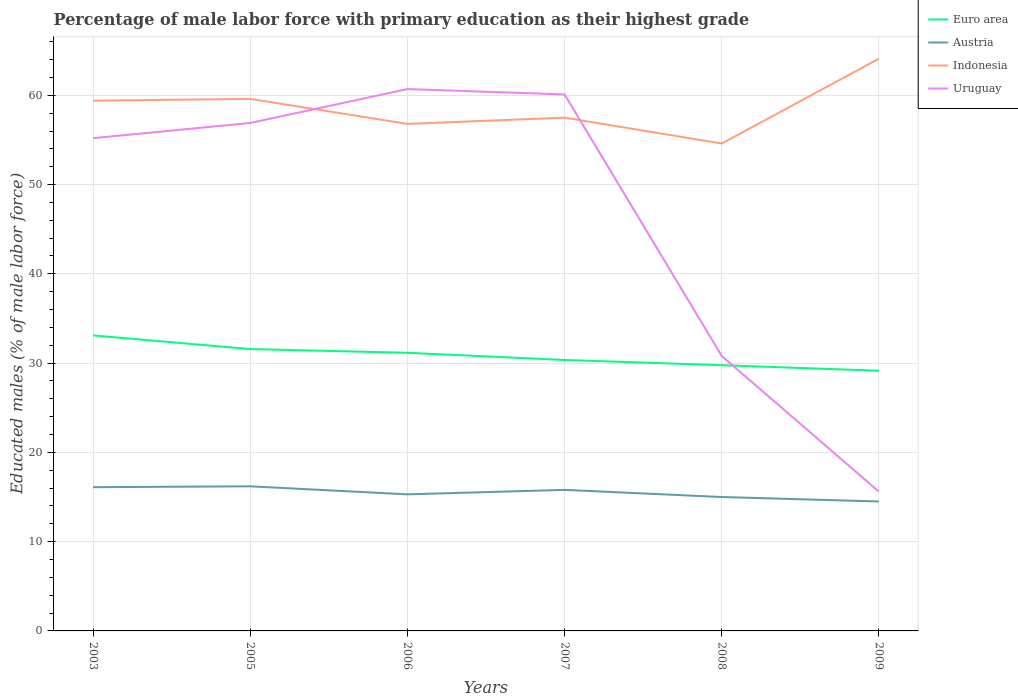Across all years, what is the maximum percentage of male labor force with primary education in Indonesia?
Offer a very short reply. 54.6. What is the total percentage of male labor force with primary education in Euro area in the graph?
Provide a succinct answer. 1.95. What is the difference between the highest and the second highest percentage of male labor force with primary education in Indonesia?
Your answer should be compact. 9.5. What is the difference between the highest and the lowest percentage of male labor force with primary education in Indonesia?
Make the answer very short. 3. Is the percentage of male labor force with primary education in Indonesia strictly greater than the percentage of male labor force with primary education in Uruguay over the years?
Keep it short and to the point. No. How many years are there in the graph?
Keep it short and to the point. 6. Are the values on the major ticks of Y-axis written in scientific E-notation?
Provide a succinct answer. No. Does the graph contain any zero values?
Your answer should be compact. No. Does the graph contain grids?
Your answer should be compact. Yes. Where does the legend appear in the graph?
Offer a very short reply. Top right. How are the legend labels stacked?
Your response must be concise. Vertical. What is the title of the graph?
Provide a short and direct response. Percentage of male labor force with primary education as their highest grade. Does "Panama" appear as one of the legend labels in the graph?
Keep it short and to the point. No. What is the label or title of the Y-axis?
Ensure brevity in your answer.  Educated males (% of male labor force). What is the Educated males (% of male labor force) of Euro area in 2003?
Make the answer very short. 33.11. What is the Educated males (% of male labor force) in Austria in 2003?
Ensure brevity in your answer.  16.1. What is the Educated males (% of male labor force) of Indonesia in 2003?
Offer a very short reply. 59.4. What is the Educated males (% of male labor force) in Uruguay in 2003?
Ensure brevity in your answer.  55.2. What is the Educated males (% of male labor force) in Euro area in 2005?
Give a very brief answer. 31.57. What is the Educated males (% of male labor force) in Austria in 2005?
Your response must be concise. 16.2. What is the Educated males (% of male labor force) in Indonesia in 2005?
Your response must be concise. 59.6. What is the Educated males (% of male labor force) of Uruguay in 2005?
Provide a short and direct response. 56.9. What is the Educated males (% of male labor force) of Euro area in 2006?
Your response must be concise. 31.16. What is the Educated males (% of male labor force) in Austria in 2006?
Provide a succinct answer. 15.3. What is the Educated males (% of male labor force) in Indonesia in 2006?
Offer a terse response. 56.8. What is the Educated males (% of male labor force) of Uruguay in 2006?
Your answer should be compact. 60.7. What is the Educated males (% of male labor force) of Euro area in 2007?
Your answer should be compact. 30.35. What is the Educated males (% of male labor force) in Austria in 2007?
Your response must be concise. 15.8. What is the Educated males (% of male labor force) of Indonesia in 2007?
Ensure brevity in your answer.  57.5. What is the Educated males (% of male labor force) of Uruguay in 2007?
Offer a very short reply. 60.1. What is the Educated males (% of male labor force) in Euro area in 2008?
Offer a very short reply. 29.77. What is the Educated males (% of male labor force) in Austria in 2008?
Provide a succinct answer. 15. What is the Educated males (% of male labor force) in Indonesia in 2008?
Make the answer very short. 54.6. What is the Educated males (% of male labor force) of Uruguay in 2008?
Offer a very short reply. 30.8. What is the Educated males (% of male labor force) of Euro area in 2009?
Give a very brief answer. 29.15. What is the Educated males (% of male labor force) of Austria in 2009?
Keep it short and to the point. 14.5. What is the Educated males (% of male labor force) of Indonesia in 2009?
Your answer should be very brief. 64.1. What is the Educated males (% of male labor force) in Uruguay in 2009?
Your answer should be compact. 15.6. Across all years, what is the maximum Educated males (% of male labor force) of Euro area?
Provide a short and direct response. 33.11. Across all years, what is the maximum Educated males (% of male labor force) in Austria?
Your answer should be compact. 16.2. Across all years, what is the maximum Educated males (% of male labor force) in Indonesia?
Your response must be concise. 64.1. Across all years, what is the maximum Educated males (% of male labor force) of Uruguay?
Ensure brevity in your answer.  60.7. Across all years, what is the minimum Educated males (% of male labor force) in Euro area?
Offer a very short reply. 29.15. Across all years, what is the minimum Educated males (% of male labor force) of Austria?
Provide a succinct answer. 14.5. Across all years, what is the minimum Educated males (% of male labor force) of Indonesia?
Your answer should be very brief. 54.6. Across all years, what is the minimum Educated males (% of male labor force) in Uruguay?
Your response must be concise. 15.6. What is the total Educated males (% of male labor force) of Euro area in the graph?
Offer a very short reply. 185.1. What is the total Educated males (% of male labor force) in Austria in the graph?
Your response must be concise. 92.9. What is the total Educated males (% of male labor force) of Indonesia in the graph?
Offer a very short reply. 352. What is the total Educated males (% of male labor force) of Uruguay in the graph?
Your answer should be very brief. 279.3. What is the difference between the Educated males (% of male labor force) in Euro area in 2003 and that in 2005?
Your response must be concise. 1.53. What is the difference between the Educated males (% of male labor force) in Austria in 2003 and that in 2005?
Provide a short and direct response. -0.1. What is the difference between the Educated males (% of male labor force) in Indonesia in 2003 and that in 2005?
Your response must be concise. -0.2. What is the difference between the Educated males (% of male labor force) in Euro area in 2003 and that in 2006?
Your answer should be compact. 1.95. What is the difference between the Educated males (% of male labor force) of Austria in 2003 and that in 2006?
Your answer should be compact. 0.8. What is the difference between the Educated males (% of male labor force) of Uruguay in 2003 and that in 2006?
Keep it short and to the point. -5.5. What is the difference between the Educated males (% of male labor force) in Euro area in 2003 and that in 2007?
Offer a very short reply. 2.75. What is the difference between the Educated males (% of male labor force) of Austria in 2003 and that in 2007?
Ensure brevity in your answer.  0.3. What is the difference between the Educated males (% of male labor force) in Euro area in 2003 and that in 2008?
Give a very brief answer. 3.34. What is the difference between the Educated males (% of male labor force) in Uruguay in 2003 and that in 2008?
Keep it short and to the point. 24.4. What is the difference between the Educated males (% of male labor force) of Euro area in 2003 and that in 2009?
Keep it short and to the point. 3.96. What is the difference between the Educated males (% of male labor force) of Indonesia in 2003 and that in 2009?
Keep it short and to the point. -4.7. What is the difference between the Educated males (% of male labor force) in Uruguay in 2003 and that in 2009?
Keep it short and to the point. 39.6. What is the difference between the Educated males (% of male labor force) in Euro area in 2005 and that in 2006?
Provide a short and direct response. 0.41. What is the difference between the Educated males (% of male labor force) in Austria in 2005 and that in 2006?
Provide a short and direct response. 0.9. What is the difference between the Educated males (% of male labor force) in Euro area in 2005 and that in 2007?
Provide a succinct answer. 1.22. What is the difference between the Educated males (% of male labor force) in Austria in 2005 and that in 2007?
Ensure brevity in your answer.  0.4. What is the difference between the Educated males (% of male labor force) in Indonesia in 2005 and that in 2007?
Your response must be concise. 2.1. What is the difference between the Educated males (% of male labor force) in Uruguay in 2005 and that in 2007?
Provide a succinct answer. -3.2. What is the difference between the Educated males (% of male labor force) in Euro area in 2005 and that in 2008?
Your answer should be compact. 1.81. What is the difference between the Educated males (% of male labor force) in Indonesia in 2005 and that in 2008?
Your response must be concise. 5. What is the difference between the Educated males (% of male labor force) of Uruguay in 2005 and that in 2008?
Keep it short and to the point. 26.1. What is the difference between the Educated males (% of male labor force) of Euro area in 2005 and that in 2009?
Your answer should be compact. 2.43. What is the difference between the Educated males (% of male labor force) of Austria in 2005 and that in 2009?
Your answer should be very brief. 1.7. What is the difference between the Educated males (% of male labor force) in Indonesia in 2005 and that in 2009?
Give a very brief answer. -4.5. What is the difference between the Educated males (% of male labor force) in Uruguay in 2005 and that in 2009?
Offer a terse response. 41.3. What is the difference between the Educated males (% of male labor force) of Euro area in 2006 and that in 2007?
Give a very brief answer. 0.81. What is the difference between the Educated males (% of male labor force) of Indonesia in 2006 and that in 2007?
Keep it short and to the point. -0.7. What is the difference between the Educated males (% of male labor force) in Uruguay in 2006 and that in 2007?
Your answer should be compact. 0.6. What is the difference between the Educated males (% of male labor force) in Euro area in 2006 and that in 2008?
Offer a very short reply. 1.39. What is the difference between the Educated males (% of male labor force) in Uruguay in 2006 and that in 2008?
Offer a very short reply. 29.9. What is the difference between the Educated males (% of male labor force) of Euro area in 2006 and that in 2009?
Make the answer very short. 2.01. What is the difference between the Educated males (% of male labor force) of Indonesia in 2006 and that in 2009?
Offer a very short reply. -7.3. What is the difference between the Educated males (% of male labor force) of Uruguay in 2006 and that in 2009?
Keep it short and to the point. 45.1. What is the difference between the Educated males (% of male labor force) in Euro area in 2007 and that in 2008?
Offer a very short reply. 0.59. What is the difference between the Educated males (% of male labor force) of Austria in 2007 and that in 2008?
Your response must be concise. 0.8. What is the difference between the Educated males (% of male labor force) of Indonesia in 2007 and that in 2008?
Give a very brief answer. 2.9. What is the difference between the Educated males (% of male labor force) of Uruguay in 2007 and that in 2008?
Give a very brief answer. 29.3. What is the difference between the Educated males (% of male labor force) in Euro area in 2007 and that in 2009?
Give a very brief answer. 1.21. What is the difference between the Educated males (% of male labor force) of Austria in 2007 and that in 2009?
Keep it short and to the point. 1.3. What is the difference between the Educated males (% of male labor force) in Uruguay in 2007 and that in 2009?
Your answer should be very brief. 44.5. What is the difference between the Educated males (% of male labor force) in Euro area in 2008 and that in 2009?
Offer a very short reply. 0.62. What is the difference between the Educated males (% of male labor force) in Austria in 2008 and that in 2009?
Provide a short and direct response. 0.5. What is the difference between the Educated males (% of male labor force) of Euro area in 2003 and the Educated males (% of male labor force) of Austria in 2005?
Provide a succinct answer. 16.91. What is the difference between the Educated males (% of male labor force) in Euro area in 2003 and the Educated males (% of male labor force) in Indonesia in 2005?
Offer a very short reply. -26.49. What is the difference between the Educated males (% of male labor force) in Euro area in 2003 and the Educated males (% of male labor force) in Uruguay in 2005?
Your answer should be very brief. -23.79. What is the difference between the Educated males (% of male labor force) of Austria in 2003 and the Educated males (% of male labor force) of Indonesia in 2005?
Provide a short and direct response. -43.5. What is the difference between the Educated males (% of male labor force) of Austria in 2003 and the Educated males (% of male labor force) of Uruguay in 2005?
Offer a terse response. -40.8. What is the difference between the Educated males (% of male labor force) of Euro area in 2003 and the Educated males (% of male labor force) of Austria in 2006?
Provide a succinct answer. 17.81. What is the difference between the Educated males (% of male labor force) of Euro area in 2003 and the Educated males (% of male labor force) of Indonesia in 2006?
Provide a short and direct response. -23.69. What is the difference between the Educated males (% of male labor force) in Euro area in 2003 and the Educated males (% of male labor force) in Uruguay in 2006?
Keep it short and to the point. -27.59. What is the difference between the Educated males (% of male labor force) of Austria in 2003 and the Educated males (% of male labor force) of Indonesia in 2006?
Provide a succinct answer. -40.7. What is the difference between the Educated males (% of male labor force) in Austria in 2003 and the Educated males (% of male labor force) in Uruguay in 2006?
Your answer should be compact. -44.6. What is the difference between the Educated males (% of male labor force) in Indonesia in 2003 and the Educated males (% of male labor force) in Uruguay in 2006?
Your answer should be compact. -1.3. What is the difference between the Educated males (% of male labor force) in Euro area in 2003 and the Educated males (% of male labor force) in Austria in 2007?
Ensure brevity in your answer.  17.31. What is the difference between the Educated males (% of male labor force) in Euro area in 2003 and the Educated males (% of male labor force) in Indonesia in 2007?
Offer a very short reply. -24.39. What is the difference between the Educated males (% of male labor force) in Euro area in 2003 and the Educated males (% of male labor force) in Uruguay in 2007?
Give a very brief answer. -26.99. What is the difference between the Educated males (% of male labor force) of Austria in 2003 and the Educated males (% of male labor force) of Indonesia in 2007?
Your answer should be very brief. -41.4. What is the difference between the Educated males (% of male labor force) of Austria in 2003 and the Educated males (% of male labor force) of Uruguay in 2007?
Give a very brief answer. -44. What is the difference between the Educated males (% of male labor force) of Euro area in 2003 and the Educated males (% of male labor force) of Austria in 2008?
Make the answer very short. 18.11. What is the difference between the Educated males (% of male labor force) of Euro area in 2003 and the Educated males (% of male labor force) of Indonesia in 2008?
Give a very brief answer. -21.49. What is the difference between the Educated males (% of male labor force) in Euro area in 2003 and the Educated males (% of male labor force) in Uruguay in 2008?
Keep it short and to the point. 2.31. What is the difference between the Educated males (% of male labor force) of Austria in 2003 and the Educated males (% of male labor force) of Indonesia in 2008?
Give a very brief answer. -38.5. What is the difference between the Educated males (% of male labor force) of Austria in 2003 and the Educated males (% of male labor force) of Uruguay in 2008?
Provide a short and direct response. -14.7. What is the difference between the Educated males (% of male labor force) in Indonesia in 2003 and the Educated males (% of male labor force) in Uruguay in 2008?
Your answer should be compact. 28.6. What is the difference between the Educated males (% of male labor force) in Euro area in 2003 and the Educated males (% of male labor force) in Austria in 2009?
Your answer should be very brief. 18.61. What is the difference between the Educated males (% of male labor force) of Euro area in 2003 and the Educated males (% of male labor force) of Indonesia in 2009?
Keep it short and to the point. -30.99. What is the difference between the Educated males (% of male labor force) of Euro area in 2003 and the Educated males (% of male labor force) of Uruguay in 2009?
Offer a terse response. 17.51. What is the difference between the Educated males (% of male labor force) of Austria in 2003 and the Educated males (% of male labor force) of Indonesia in 2009?
Your answer should be very brief. -48. What is the difference between the Educated males (% of male labor force) in Indonesia in 2003 and the Educated males (% of male labor force) in Uruguay in 2009?
Offer a very short reply. 43.8. What is the difference between the Educated males (% of male labor force) of Euro area in 2005 and the Educated males (% of male labor force) of Austria in 2006?
Provide a succinct answer. 16.27. What is the difference between the Educated males (% of male labor force) of Euro area in 2005 and the Educated males (% of male labor force) of Indonesia in 2006?
Make the answer very short. -25.23. What is the difference between the Educated males (% of male labor force) of Euro area in 2005 and the Educated males (% of male labor force) of Uruguay in 2006?
Provide a succinct answer. -29.13. What is the difference between the Educated males (% of male labor force) of Austria in 2005 and the Educated males (% of male labor force) of Indonesia in 2006?
Provide a short and direct response. -40.6. What is the difference between the Educated males (% of male labor force) in Austria in 2005 and the Educated males (% of male labor force) in Uruguay in 2006?
Make the answer very short. -44.5. What is the difference between the Educated males (% of male labor force) of Indonesia in 2005 and the Educated males (% of male labor force) of Uruguay in 2006?
Your answer should be compact. -1.1. What is the difference between the Educated males (% of male labor force) in Euro area in 2005 and the Educated males (% of male labor force) in Austria in 2007?
Provide a short and direct response. 15.77. What is the difference between the Educated males (% of male labor force) of Euro area in 2005 and the Educated males (% of male labor force) of Indonesia in 2007?
Your answer should be compact. -25.93. What is the difference between the Educated males (% of male labor force) in Euro area in 2005 and the Educated males (% of male labor force) in Uruguay in 2007?
Your answer should be compact. -28.53. What is the difference between the Educated males (% of male labor force) of Austria in 2005 and the Educated males (% of male labor force) of Indonesia in 2007?
Keep it short and to the point. -41.3. What is the difference between the Educated males (% of male labor force) of Austria in 2005 and the Educated males (% of male labor force) of Uruguay in 2007?
Provide a succinct answer. -43.9. What is the difference between the Educated males (% of male labor force) in Euro area in 2005 and the Educated males (% of male labor force) in Austria in 2008?
Offer a very short reply. 16.57. What is the difference between the Educated males (% of male labor force) of Euro area in 2005 and the Educated males (% of male labor force) of Indonesia in 2008?
Provide a short and direct response. -23.03. What is the difference between the Educated males (% of male labor force) of Euro area in 2005 and the Educated males (% of male labor force) of Uruguay in 2008?
Your answer should be very brief. 0.77. What is the difference between the Educated males (% of male labor force) of Austria in 2005 and the Educated males (% of male labor force) of Indonesia in 2008?
Keep it short and to the point. -38.4. What is the difference between the Educated males (% of male labor force) of Austria in 2005 and the Educated males (% of male labor force) of Uruguay in 2008?
Give a very brief answer. -14.6. What is the difference between the Educated males (% of male labor force) in Indonesia in 2005 and the Educated males (% of male labor force) in Uruguay in 2008?
Offer a very short reply. 28.8. What is the difference between the Educated males (% of male labor force) of Euro area in 2005 and the Educated males (% of male labor force) of Austria in 2009?
Offer a terse response. 17.07. What is the difference between the Educated males (% of male labor force) in Euro area in 2005 and the Educated males (% of male labor force) in Indonesia in 2009?
Provide a succinct answer. -32.53. What is the difference between the Educated males (% of male labor force) in Euro area in 2005 and the Educated males (% of male labor force) in Uruguay in 2009?
Provide a short and direct response. 15.97. What is the difference between the Educated males (% of male labor force) in Austria in 2005 and the Educated males (% of male labor force) in Indonesia in 2009?
Your answer should be compact. -47.9. What is the difference between the Educated males (% of male labor force) in Austria in 2005 and the Educated males (% of male labor force) in Uruguay in 2009?
Offer a terse response. 0.6. What is the difference between the Educated males (% of male labor force) in Euro area in 2006 and the Educated males (% of male labor force) in Austria in 2007?
Your response must be concise. 15.36. What is the difference between the Educated males (% of male labor force) of Euro area in 2006 and the Educated males (% of male labor force) of Indonesia in 2007?
Your answer should be compact. -26.34. What is the difference between the Educated males (% of male labor force) of Euro area in 2006 and the Educated males (% of male labor force) of Uruguay in 2007?
Make the answer very short. -28.94. What is the difference between the Educated males (% of male labor force) in Austria in 2006 and the Educated males (% of male labor force) in Indonesia in 2007?
Your response must be concise. -42.2. What is the difference between the Educated males (% of male labor force) in Austria in 2006 and the Educated males (% of male labor force) in Uruguay in 2007?
Give a very brief answer. -44.8. What is the difference between the Educated males (% of male labor force) of Indonesia in 2006 and the Educated males (% of male labor force) of Uruguay in 2007?
Your answer should be compact. -3.3. What is the difference between the Educated males (% of male labor force) of Euro area in 2006 and the Educated males (% of male labor force) of Austria in 2008?
Provide a short and direct response. 16.16. What is the difference between the Educated males (% of male labor force) of Euro area in 2006 and the Educated males (% of male labor force) of Indonesia in 2008?
Give a very brief answer. -23.44. What is the difference between the Educated males (% of male labor force) of Euro area in 2006 and the Educated males (% of male labor force) of Uruguay in 2008?
Keep it short and to the point. 0.36. What is the difference between the Educated males (% of male labor force) in Austria in 2006 and the Educated males (% of male labor force) in Indonesia in 2008?
Provide a short and direct response. -39.3. What is the difference between the Educated males (% of male labor force) in Austria in 2006 and the Educated males (% of male labor force) in Uruguay in 2008?
Keep it short and to the point. -15.5. What is the difference between the Educated males (% of male labor force) of Indonesia in 2006 and the Educated males (% of male labor force) of Uruguay in 2008?
Offer a very short reply. 26. What is the difference between the Educated males (% of male labor force) of Euro area in 2006 and the Educated males (% of male labor force) of Austria in 2009?
Make the answer very short. 16.66. What is the difference between the Educated males (% of male labor force) in Euro area in 2006 and the Educated males (% of male labor force) in Indonesia in 2009?
Make the answer very short. -32.94. What is the difference between the Educated males (% of male labor force) of Euro area in 2006 and the Educated males (% of male labor force) of Uruguay in 2009?
Provide a succinct answer. 15.56. What is the difference between the Educated males (% of male labor force) of Austria in 2006 and the Educated males (% of male labor force) of Indonesia in 2009?
Your response must be concise. -48.8. What is the difference between the Educated males (% of male labor force) in Indonesia in 2006 and the Educated males (% of male labor force) in Uruguay in 2009?
Offer a terse response. 41.2. What is the difference between the Educated males (% of male labor force) in Euro area in 2007 and the Educated males (% of male labor force) in Austria in 2008?
Keep it short and to the point. 15.35. What is the difference between the Educated males (% of male labor force) of Euro area in 2007 and the Educated males (% of male labor force) of Indonesia in 2008?
Make the answer very short. -24.25. What is the difference between the Educated males (% of male labor force) in Euro area in 2007 and the Educated males (% of male labor force) in Uruguay in 2008?
Offer a terse response. -0.45. What is the difference between the Educated males (% of male labor force) in Austria in 2007 and the Educated males (% of male labor force) in Indonesia in 2008?
Your answer should be compact. -38.8. What is the difference between the Educated males (% of male labor force) of Austria in 2007 and the Educated males (% of male labor force) of Uruguay in 2008?
Your answer should be very brief. -15. What is the difference between the Educated males (% of male labor force) of Indonesia in 2007 and the Educated males (% of male labor force) of Uruguay in 2008?
Ensure brevity in your answer.  26.7. What is the difference between the Educated males (% of male labor force) in Euro area in 2007 and the Educated males (% of male labor force) in Austria in 2009?
Your response must be concise. 15.85. What is the difference between the Educated males (% of male labor force) of Euro area in 2007 and the Educated males (% of male labor force) of Indonesia in 2009?
Offer a terse response. -33.75. What is the difference between the Educated males (% of male labor force) in Euro area in 2007 and the Educated males (% of male labor force) in Uruguay in 2009?
Your response must be concise. 14.75. What is the difference between the Educated males (% of male labor force) in Austria in 2007 and the Educated males (% of male labor force) in Indonesia in 2009?
Provide a short and direct response. -48.3. What is the difference between the Educated males (% of male labor force) in Indonesia in 2007 and the Educated males (% of male labor force) in Uruguay in 2009?
Your answer should be very brief. 41.9. What is the difference between the Educated males (% of male labor force) in Euro area in 2008 and the Educated males (% of male labor force) in Austria in 2009?
Provide a succinct answer. 15.27. What is the difference between the Educated males (% of male labor force) in Euro area in 2008 and the Educated males (% of male labor force) in Indonesia in 2009?
Ensure brevity in your answer.  -34.33. What is the difference between the Educated males (% of male labor force) in Euro area in 2008 and the Educated males (% of male labor force) in Uruguay in 2009?
Your answer should be very brief. 14.17. What is the difference between the Educated males (% of male labor force) of Austria in 2008 and the Educated males (% of male labor force) of Indonesia in 2009?
Offer a terse response. -49.1. What is the difference between the Educated males (% of male labor force) of Austria in 2008 and the Educated males (% of male labor force) of Uruguay in 2009?
Provide a short and direct response. -0.6. What is the average Educated males (% of male labor force) of Euro area per year?
Keep it short and to the point. 30.85. What is the average Educated males (% of male labor force) in Austria per year?
Ensure brevity in your answer.  15.48. What is the average Educated males (% of male labor force) in Indonesia per year?
Offer a very short reply. 58.67. What is the average Educated males (% of male labor force) of Uruguay per year?
Offer a terse response. 46.55. In the year 2003, what is the difference between the Educated males (% of male labor force) in Euro area and Educated males (% of male labor force) in Austria?
Make the answer very short. 17.01. In the year 2003, what is the difference between the Educated males (% of male labor force) in Euro area and Educated males (% of male labor force) in Indonesia?
Give a very brief answer. -26.29. In the year 2003, what is the difference between the Educated males (% of male labor force) of Euro area and Educated males (% of male labor force) of Uruguay?
Offer a very short reply. -22.09. In the year 2003, what is the difference between the Educated males (% of male labor force) in Austria and Educated males (% of male labor force) in Indonesia?
Your response must be concise. -43.3. In the year 2003, what is the difference between the Educated males (% of male labor force) of Austria and Educated males (% of male labor force) of Uruguay?
Your response must be concise. -39.1. In the year 2005, what is the difference between the Educated males (% of male labor force) in Euro area and Educated males (% of male labor force) in Austria?
Offer a very short reply. 15.37. In the year 2005, what is the difference between the Educated males (% of male labor force) of Euro area and Educated males (% of male labor force) of Indonesia?
Your answer should be compact. -28.03. In the year 2005, what is the difference between the Educated males (% of male labor force) of Euro area and Educated males (% of male labor force) of Uruguay?
Offer a very short reply. -25.33. In the year 2005, what is the difference between the Educated males (% of male labor force) in Austria and Educated males (% of male labor force) in Indonesia?
Ensure brevity in your answer.  -43.4. In the year 2005, what is the difference between the Educated males (% of male labor force) in Austria and Educated males (% of male labor force) in Uruguay?
Your answer should be very brief. -40.7. In the year 2005, what is the difference between the Educated males (% of male labor force) in Indonesia and Educated males (% of male labor force) in Uruguay?
Offer a very short reply. 2.7. In the year 2006, what is the difference between the Educated males (% of male labor force) in Euro area and Educated males (% of male labor force) in Austria?
Your response must be concise. 15.86. In the year 2006, what is the difference between the Educated males (% of male labor force) in Euro area and Educated males (% of male labor force) in Indonesia?
Provide a short and direct response. -25.64. In the year 2006, what is the difference between the Educated males (% of male labor force) in Euro area and Educated males (% of male labor force) in Uruguay?
Your answer should be compact. -29.54. In the year 2006, what is the difference between the Educated males (% of male labor force) of Austria and Educated males (% of male labor force) of Indonesia?
Offer a terse response. -41.5. In the year 2006, what is the difference between the Educated males (% of male labor force) in Austria and Educated males (% of male labor force) in Uruguay?
Your answer should be compact. -45.4. In the year 2006, what is the difference between the Educated males (% of male labor force) of Indonesia and Educated males (% of male labor force) of Uruguay?
Make the answer very short. -3.9. In the year 2007, what is the difference between the Educated males (% of male labor force) of Euro area and Educated males (% of male labor force) of Austria?
Your answer should be very brief. 14.55. In the year 2007, what is the difference between the Educated males (% of male labor force) of Euro area and Educated males (% of male labor force) of Indonesia?
Provide a short and direct response. -27.15. In the year 2007, what is the difference between the Educated males (% of male labor force) of Euro area and Educated males (% of male labor force) of Uruguay?
Your response must be concise. -29.75. In the year 2007, what is the difference between the Educated males (% of male labor force) in Austria and Educated males (% of male labor force) in Indonesia?
Your answer should be compact. -41.7. In the year 2007, what is the difference between the Educated males (% of male labor force) in Austria and Educated males (% of male labor force) in Uruguay?
Keep it short and to the point. -44.3. In the year 2007, what is the difference between the Educated males (% of male labor force) of Indonesia and Educated males (% of male labor force) of Uruguay?
Your response must be concise. -2.6. In the year 2008, what is the difference between the Educated males (% of male labor force) in Euro area and Educated males (% of male labor force) in Austria?
Your answer should be compact. 14.77. In the year 2008, what is the difference between the Educated males (% of male labor force) of Euro area and Educated males (% of male labor force) of Indonesia?
Offer a terse response. -24.83. In the year 2008, what is the difference between the Educated males (% of male labor force) in Euro area and Educated males (% of male labor force) in Uruguay?
Your answer should be very brief. -1.03. In the year 2008, what is the difference between the Educated males (% of male labor force) in Austria and Educated males (% of male labor force) in Indonesia?
Give a very brief answer. -39.6. In the year 2008, what is the difference between the Educated males (% of male labor force) of Austria and Educated males (% of male labor force) of Uruguay?
Ensure brevity in your answer.  -15.8. In the year 2008, what is the difference between the Educated males (% of male labor force) of Indonesia and Educated males (% of male labor force) of Uruguay?
Your answer should be very brief. 23.8. In the year 2009, what is the difference between the Educated males (% of male labor force) of Euro area and Educated males (% of male labor force) of Austria?
Make the answer very short. 14.65. In the year 2009, what is the difference between the Educated males (% of male labor force) of Euro area and Educated males (% of male labor force) of Indonesia?
Your answer should be compact. -34.95. In the year 2009, what is the difference between the Educated males (% of male labor force) of Euro area and Educated males (% of male labor force) of Uruguay?
Make the answer very short. 13.55. In the year 2009, what is the difference between the Educated males (% of male labor force) in Austria and Educated males (% of male labor force) in Indonesia?
Your response must be concise. -49.6. In the year 2009, what is the difference between the Educated males (% of male labor force) in Austria and Educated males (% of male labor force) in Uruguay?
Your answer should be compact. -1.1. In the year 2009, what is the difference between the Educated males (% of male labor force) of Indonesia and Educated males (% of male labor force) of Uruguay?
Make the answer very short. 48.5. What is the ratio of the Educated males (% of male labor force) in Euro area in 2003 to that in 2005?
Your answer should be very brief. 1.05. What is the ratio of the Educated males (% of male labor force) of Austria in 2003 to that in 2005?
Provide a short and direct response. 0.99. What is the ratio of the Educated males (% of male labor force) in Indonesia in 2003 to that in 2005?
Offer a terse response. 1. What is the ratio of the Educated males (% of male labor force) of Uruguay in 2003 to that in 2005?
Your answer should be compact. 0.97. What is the ratio of the Educated males (% of male labor force) of Austria in 2003 to that in 2006?
Offer a very short reply. 1.05. What is the ratio of the Educated males (% of male labor force) of Indonesia in 2003 to that in 2006?
Your answer should be compact. 1.05. What is the ratio of the Educated males (% of male labor force) of Uruguay in 2003 to that in 2006?
Make the answer very short. 0.91. What is the ratio of the Educated males (% of male labor force) of Euro area in 2003 to that in 2007?
Provide a short and direct response. 1.09. What is the ratio of the Educated males (% of male labor force) of Austria in 2003 to that in 2007?
Your answer should be compact. 1.02. What is the ratio of the Educated males (% of male labor force) of Indonesia in 2003 to that in 2007?
Ensure brevity in your answer.  1.03. What is the ratio of the Educated males (% of male labor force) in Uruguay in 2003 to that in 2007?
Offer a terse response. 0.92. What is the ratio of the Educated males (% of male labor force) in Euro area in 2003 to that in 2008?
Offer a terse response. 1.11. What is the ratio of the Educated males (% of male labor force) in Austria in 2003 to that in 2008?
Keep it short and to the point. 1.07. What is the ratio of the Educated males (% of male labor force) of Indonesia in 2003 to that in 2008?
Provide a succinct answer. 1.09. What is the ratio of the Educated males (% of male labor force) of Uruguay in 2003 to that in 2008?
Your answer should be compact. 1.79. What is the ratio of the Educated males (% of male labor force) in Euro area in 2003 to that in 2009?
Give a very brief answer. 1.14. What is the ratio of the Educated males (% of male labor force) of Austria in 2003 to that in 2009?
Keep it short and to the point. 1.11. What is the ratio of the Educated males (% of male labor force) of Indonesia in 2003 to that in 2009?
Ensure brevity in your answer.  0.93. What is the ratio of the Educated males (% of male labor force) in Uruguay in 2003 to that in 2009?
Offer a very short reply. 3.54. What is the ratio of the Educated males (% of male labor force) of Euro area in 2005 to that in 2006?
Your response must be concise. 1.01. What is the ratio of the Educated males (% of male labor force) in Austria in 2005 to that in 2006?
Your response must be concise. 1.06. What is the ratio of the Educated males (% of male labor force) of Indonesia in 2005 to that in 2006?
Your answer should be compact. 1.05. What is the ratio of the Educated males (% of male labor force) in Uruguay in 2005 to that in 2006?
Your response must be concise. 0.94. What is the ratio of the Educated males (% of male labor force) of Euro area in 2005 to that in 2007?
Ensure brevity in your answer.  1.04. What is the ratio of the Educated males (% of male labor force) of Austria in 2005 to that in 2007?
Your answer should be compact. 1.03. What is the ratio of the Educated males (% of male labor force) of Indonesia in 2005 to that in 2007?
Provide a short and direct response. 1.04. What is the ratio of the Educated males (% of male labor force) of Uruguay in 2005 to that in 2007?
Your answer should be very brief. 0.95. What is the ratio of the Educated males (% of male labor force) in Euro area in 2005 to that in 2008?
Keep it short and to the point. 1.06. What is the ratio of the Educated males (% of male labor force) in Austria in 2005 to that in 2008?
Keep it short and to the point. 1.08. What is the ratio of the Educated males (% of male labor force) of Indonesia in 2005 to that in 2008?
Your response must be concise. 1.09. What is the ratio of the Educated males (% of male labor force) of Uruguay in 2005 to that in 2008?
Ensure brevity in your answer.  1.85. What is the ratio of the Educated males (% of male labor force) in Euro area in 2005 to that in 2009?
Provide a succinct answer. 1.08. What is the ratio of the Educated males (% of male labor force) in Austria in 2005 to that in 2009?
Provide a short and direct response. 1.12. What is the ratio of the Educated males (% of male labor force) in Indonesia in 2005 to that in 2009?
Your answer should be very brief. 0.93. What is the ratio of the Educated males (% of male labor force) of Uruguay in 2005 to that in 2009?
Your answer should be compact. 3.65. What is the ratio of the Educated males (% of male labor force) of Euro area in 2006 to that in 2007?
Your response must be concise. 1.03. What is the ratio of the Educated males (% of male labor force) in Austria in 2006 to that in 2007?
Your answer should be very brief. 0.97. What is the ratio of the Educated males (% of male labor force) in Indonesia in 2006 to that in 2007?
Keep it short and to the point. 0.99. What is the ratio of the Educated males (% of male labor force) of Uruguay in 2006 to that in 2007?
Keep it short and to the point. 1.01. What is the ratio of the Educated males (% of male labor force) in Euro area in 2006 to that in 2008?
Make the answer very short. 1.05. What is the ratio of the Educated males (% of male labor force) in Austria in 2006 to that in 2008?
Offer a terse response. 1.02. What is the ratio of the Educated males (% of male labor force) in Indonesia in 2006 to that in 2008?
Provide a short and direct response. 1.04. What is the ratio of the Educated males (% of male labor force) in Uruguay in 2006 to that in 2008?
Your answer should be compact. 1.97. What is the ratio of the Educated males (% of male labor force) of Euro area in 2006 to that in 2009?
Offer a very short reply. 1.07. What is the ratio of the Educated males (% of male labor force) in Austria in 2006 to that in 2009?
Make the answer very short. 1.06. What is the ratio of the Educated males (% of male labor force) of Indonesia in 2006 to that in 2009?
Your response must be concise. 0.89. What is the ratio of the Educated males (% of male labor force) in Uruguay in 2006 to that in 2009?
Offer a terse response. 3.89. What is the ratio of the Educated males (% of male labor force) of Euro area in 2007 to that in 2008?
Keep it short and to the point. 1.02. What is the ratio of the Educated males (% of male labor force) in Austria in 2007 to that in 2008?
Provide a short and direct response. 1.05. What is the ratio of the Educated males (% of male labor force) of Indonesia in 2007 to that in 2008?
Provide a short and direct response. 1.05. What is the ratio of the Educated males (% of male labor force) in Uruguay in 2007 to that in 2008?
Keep it short and to the point. 1.95. What is the ratio of the Educated males (% of male labor force) in Euro area in 2007 to that in 2009?
Keep it short and to the point. 1.04. What is the ratio of the Educated males (% of male labor force) of Austria in 2007 to that in 2009?
Your response must be concise. 1.09. What is the ratio of the Educated males (% of male labor force) of Indonesia in 2007 to that in 2009?
Your answer should be compact. 0.9. What is the ratio of the Educated males (% of male labor force) of Uruguay in 2007 to that in 2009?
Your response must be concise. 3.85. What is the ratio of the Educated males (% of male labor force) in Euro area in 2008 to that in 2009?
Keep it short and to the point. 1.02. What is the ratio of the Educated males (% of male labor force) in Austria in 2008 to that in 2009?
Your response must be concise. 1.03. What is the ratio of the Educated males (% of male labor force) in Indonesia in 2008 to that in 2009?
Your response must be concise. 0.85. What is the ratio of the Educated males (% of male labor force) in Uruguay in 2008 to that in 2009?
Ensure brevity in your answer.  1.97. What is the difference between the highest and the second highest Educated males (% of male labor force) of Euro area?
Give a very brief answer. 1.53. What is the difference between the highest and the second highest Educated males (% of male labor force) of Austria?
Provide a short and direct response. 0.1. What is the difference between the highest and the second highest Educated males (% of male labor force) in Uruguay?
Give a very brief answer. 0.6. What is the difference between the highest and the lowest Educated males (% of male labor force) of Euro area?
Your answer should be compact. 3.96. What is the difference between the highest and the lowest Educated males (% of male labor force) of Indonesia?
Ensure brevity in your answer.  9.5. What is the difference between the highest and the lowest Educated males (% of male labor force) in Uruguay?
Ensure brevity in your answer.  45.1. 